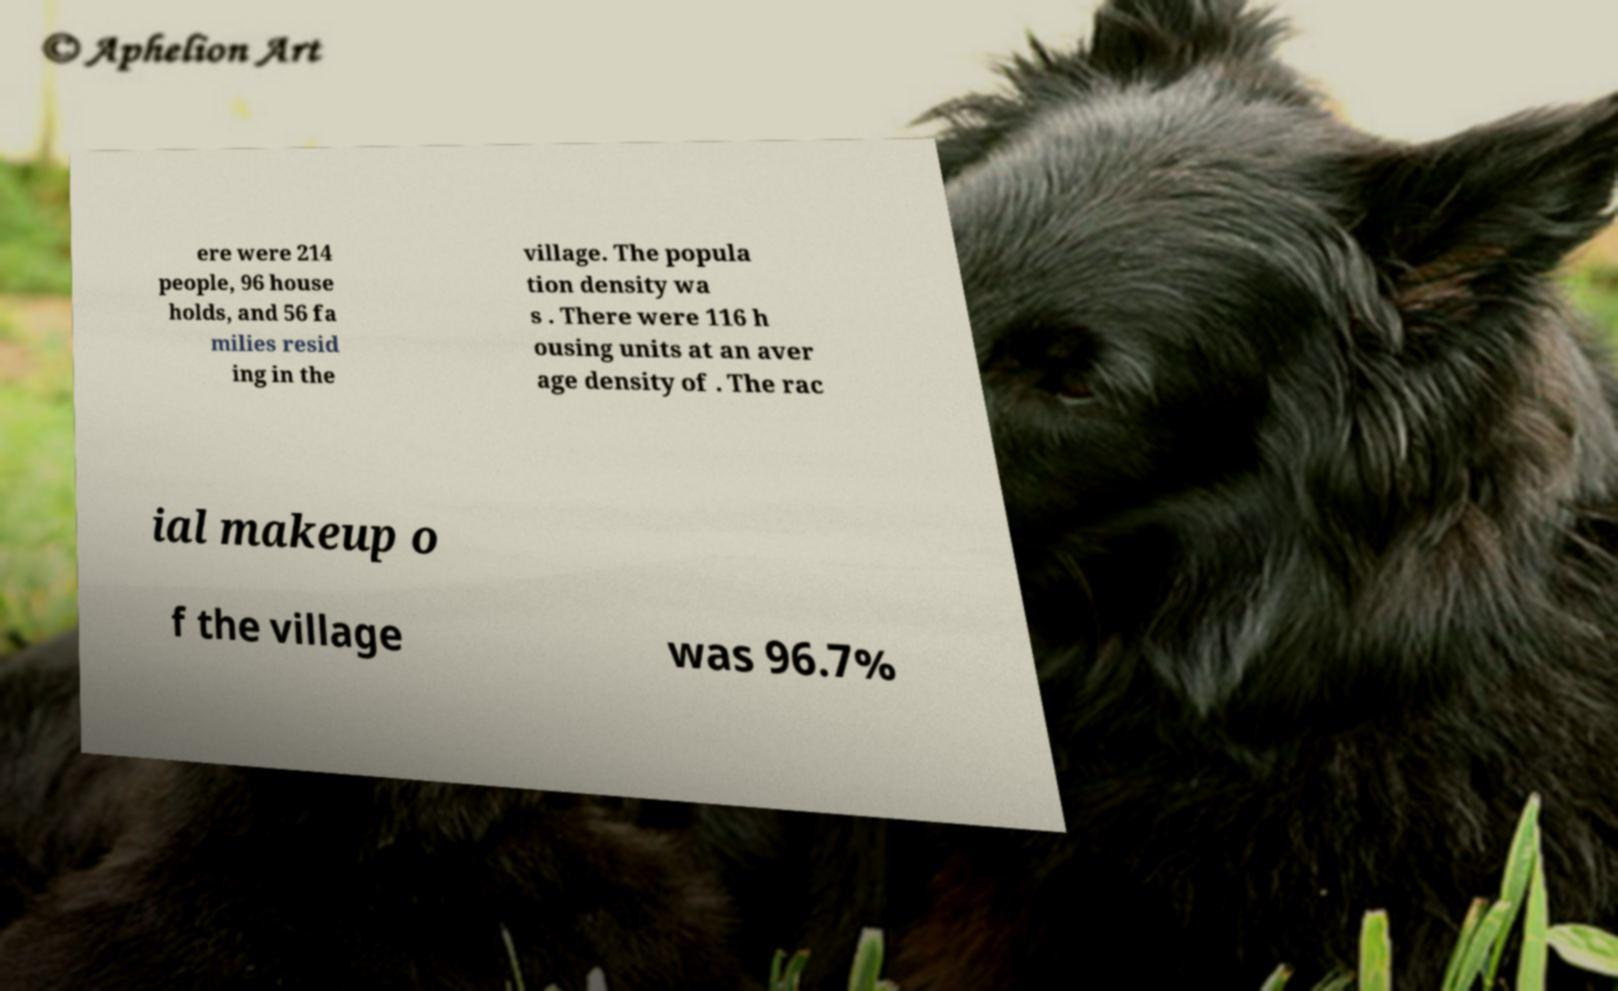What messages or text are displayed in this image? I need them in a readable, typed format. ere were 214 people, 96 house holds, and 56 fa milies resid ing in the village. The popula tion density wa s . There were 116 h ousing units at an aver age density of . The rac ial makeup o f the village was 96.7% 